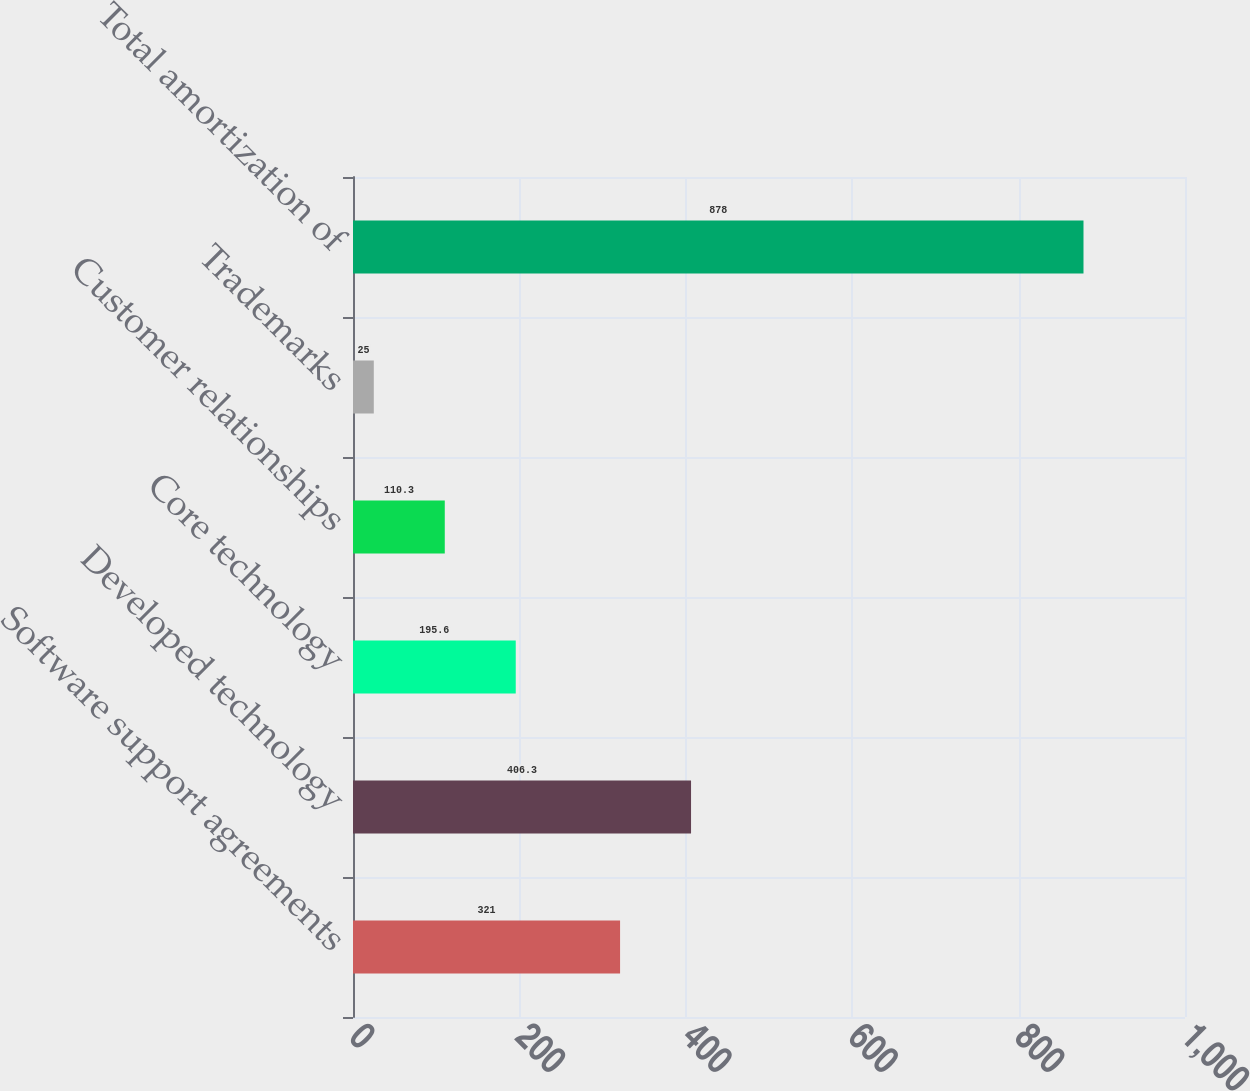Convert chart to OTSL. <chart><loc_0><loc_0><loc_500><loc_500><bar_chart><fcel>Software support agreements<fcel>Developed technology<fcel>Core technology<fcel>Customer relationships<fcel>Trademarks<fcel>Total amortization of<nl><fcel>321<fcel>406.3<fcel>195.6<fcel>110.3<fcel>25<fcel>878<nl></chart> 